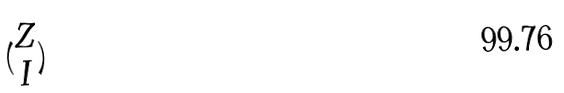<formula> <loc_0><loc_0><loc_500><loc_500>( \begin{matrix} Z \\ I \end{matrix} )</formula> 